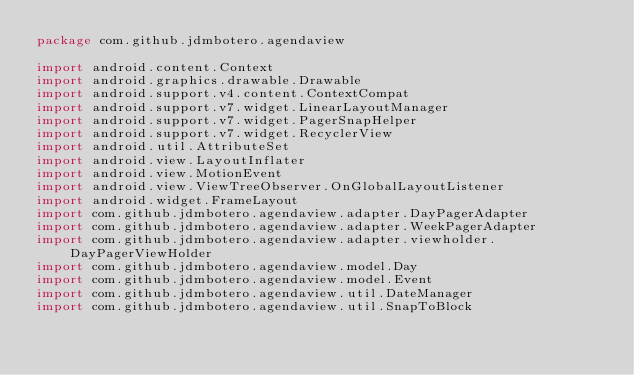<code> <loc_0><loc_0><loc_500><loc_500><_Kotlin_>package com.github.jdmbotero.agendaview

import android.content.Context
import android.graphics.drawable.Drawable
import android.support.v4.content.ContextCompat
import android.support.v7.widget.LinearLayoutManager
import android.support.v7.widget.PagerSnapHelper
import android.support.v7.widget.RecyclerView
import android.util.AttributeSet
import android.view.LayoutInflater
import android.view.MotionEvent
import android.view.ViewTreeObserver.OnGlobalLayoutListener
import android.widget.FrameLayout
import com.github.jdmbotero.agendaview.adapter.DayPagerAdapter
import com.github.jdmbotero.agendaview.adapter.WeekPagerAdapter
import com.github.jdmbotero.agendaview.adapter.viewholder.DayPagerViewHolder
import com.github.jdmbotero.agendaview.model.Day
import com.github.jdmbotero.agendaview.model.Event
import com.github.jdmbotero.agendaview.util.DateManager
import com.github.jdmbotero.agendaview.util.SnapToBlock</code> 